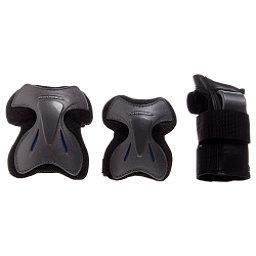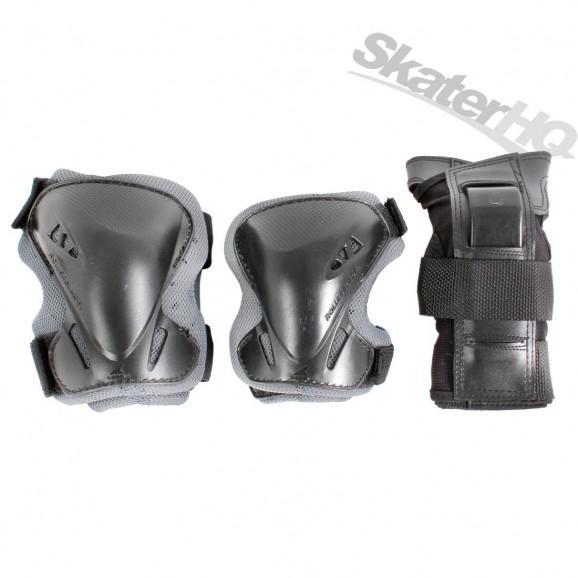The first image is the image on the left, the second image is the image on the right. Evaluate the accuracy of this statement regarding the images: "there are 6 kneepads per image pair". Is it true? Answer yes or no. Yes. The first image is the image on the left, the second image is the image on the right. Considering the images on both sides, is "There are exactly six pads in total." valid? Answer yes or no. Yes. 